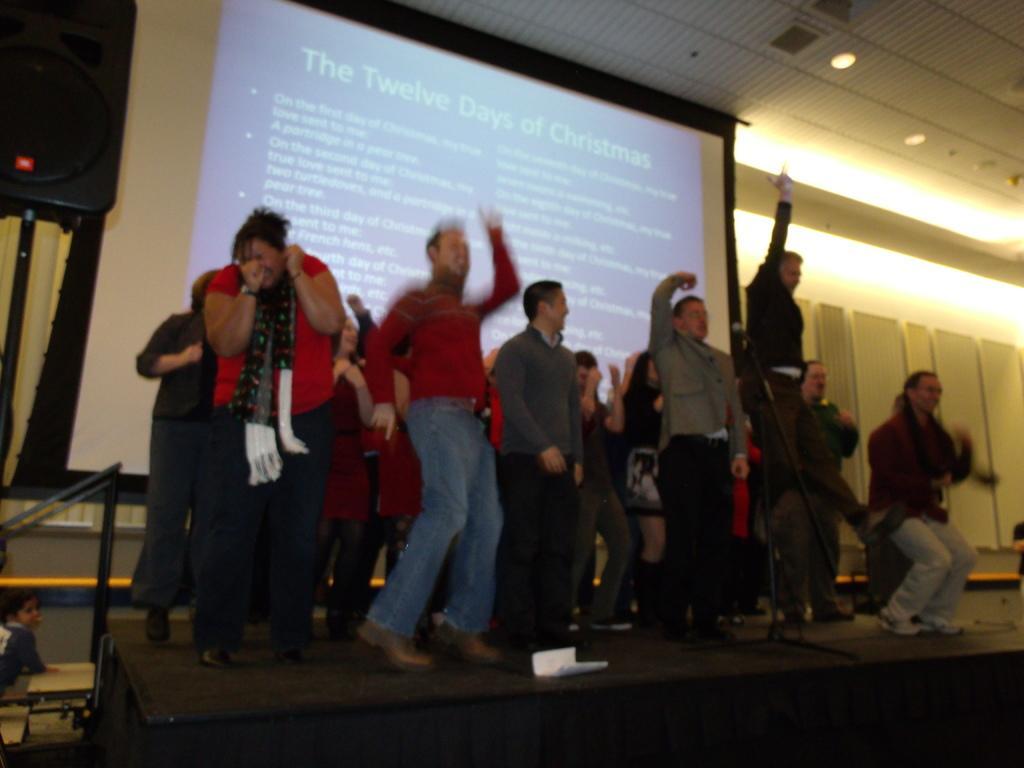Please provide a concise description of this image. In this picture I can see a group of people in the middle, in the background there is a projector screen. At the top there are ceiling lights, on the left side there is a kid on the stairs. 